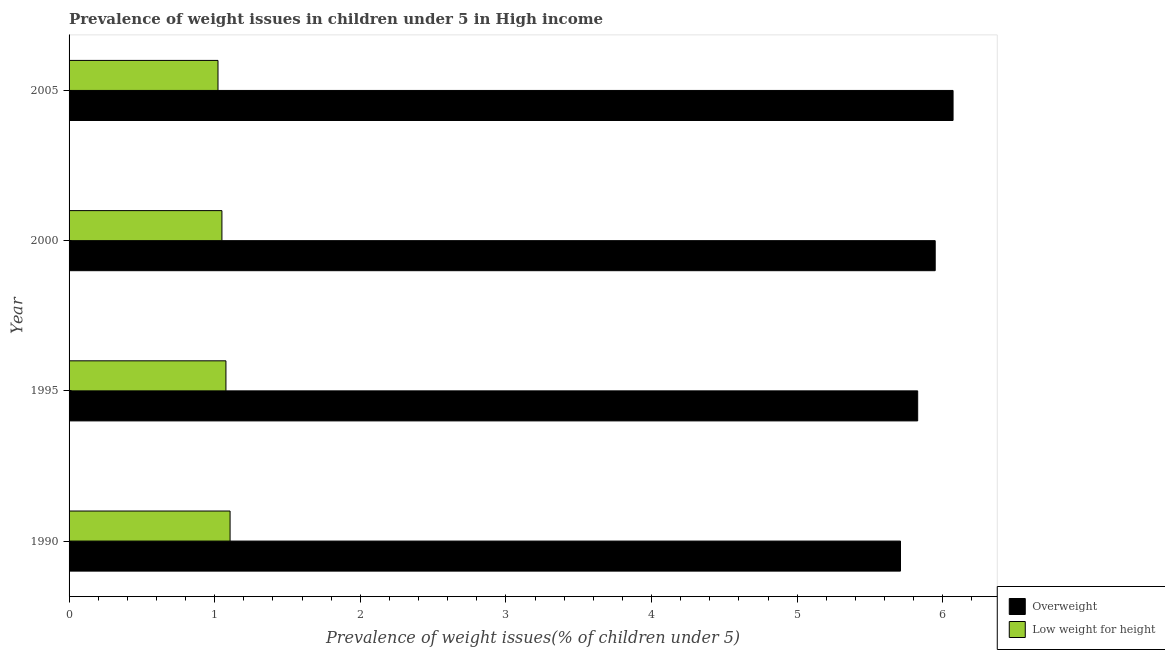Are the number of bars per tick equal to the number of legend labels?
Ensure brevity in your answer.  Yes. How many bars are there on the 4th tick from the bottom?
Ensure brevity in your answer.  2. What is the label of the 3rd group of bars from the top?
Keep it short and to the point. 1995. In how many cases, is the number of bars for a given year not equal to the number of legend labels?
Offer a very short reply. 0. What is the percentage of underweight children in 1995?
Offer a very short reply. 1.08. Across all years, what is the maximum percentage of underweight children?
Give a very brief answer. 1.11. Across all years, what is the minimum percentage of underweight children?
Keep it short and to the point. 1.02. In which year was the percentage of overweight children minimum?
Make the answer very short. 1990. What is the total percentage of underweight children in the graph?
Offer a very short reply. 4.26. What is the difference between the percentage of underweight children in 1995 and that in 2005?
Make the answer very short. 0.06. What is the difference between the percentage of overweight children in 2005 and the percentage of underweight children in 1990?
Keep it short and to the point. 4.96. What is the average percentage of underweight children per year?
Make the answer very short. 1.06. In the year 2000, what is the difference between the percentage of underweight children and percentage of overweight children?
Keep it short and to the point. -4.9. Is the difference between the percentage of underweight children in 1990 and 1995 greater than the difference between the percentage of overweight children in 1990 and 1995?
Provide a succinct answer. Yes. What is the difference between the highest and the second highest percentage of overweight children?
Provide a short and direct response. 0.12. What does the 2nd bar from the top in 1990 represents?
Offer a terse response. Overweight. What does the 2nd bar from the bottom in 1990 represents?
Keep it short and to the point. Low weight for height. Are all the bars in the graph horizontal?
Give a very brief answer. Yes. What is the difference between two consecutive major ticks on the X-axis?
Your answer should be compact. 1. Does the graph contain any zero values?
Keep it short and to the point. No. What is the title of the graph?
Keep it short and to the point. Prevalence of weight issues in children under 5 in High income. What is the label or title of the X-axis?
Your answer should be very brief. Prevalence of weight issues(% of children under 5). What is the label or title of the Y-axis?
Give a very brief answer. Year. What is the Prevalence of weight issues(% of children under 5) of Overweight in 1990?
Your answer should be very brief. 5.71. What is the Prevalence of weight issues(% of children under 5) in Low weight for height in 1990?
Your answer should be compact. 1.11. What is the Prevalence of weight issues(% of children under 5) in Overweight in 1995?
Your response must be concise. 5.83. What is the Prevalence of weight issues(% of children under 5) of Low weight for height in 1995?
Provide a short and direct response. 1.08. What is the Prevalence of weight issues(% of children under 5) of Overweight in 2000?
Give a very brief answer. 5.95. What is the Prevalence of weight issues(% of children under 5) of Low weight for height in 2000?
Your response must be concise. 1.05. What is the Prevalence of weight issues(% of children under 5) in Overweight in 2005?
Give a very brief answer. 6.07. What is the Prevalence of weight issues(% of children under 5) in Low weight for height in 2005?
Give a very brief answer. 1.02. Across all years, what is the maximum Prevalence of weight issues(% of children under 5) in Overweight?
Ensure brevity in your answer.  6.07. Across all years, what is the maximum Prevalence of weight issues(% of children under 5) in Low weight for height?
Keep it short and to the point. 1.11. Across all years, what is the minimum Prevalence of weight issues(% of children under 5) in Overweight?
Make the answer very short. 5.71. Across all years, what is the minimum Prevalence of weight issues(% of children under 5) of Low weight for height?
Offer a terse response. 1.02. What is the total Prevalence of weight issues(% of children under 5) in Overweight in the graph?
Offer a terse response. 23.56. What is the total Prevalence of weight issues(% of children under 5) of Low weight for height in the graph?
Make the answer very short. 4.26. What is the difference between the Prevalence of weight issues(% of children under 5) in Overweight in 1990 and that in 1995?
Your answer should be very brief. -0.12. What is the difference between the Prevalence of weight issues(% of children under 5) of Low weight for height in 1990 and that in 1995?
Your answer should be compact. 0.03. What is the difference between the Prevalence of weight issues(% of children under 5) in Overweight in 1990 and that in 2000?
Provide a succinct answer. -0.24. What is the difference between the Prevalence of weight issues(% of children under 5) of Low weight for height in 1990 and that in 2000?
Provide a succinct answer. 0.06. What is the difference between the Prevalence of weight issues(% of children under 5) in Overweight in 1990 and that in 2005?
Provide a succinct answer. -0.36. What is the difference between the Prevalence of weight issues(% of children under 5) of Low weight for height in 1990 and that in 2005?
Give a very brief answer. 0.08. What is the difference between the Prevalence of weight issues(% of children under 5) in Overweight in 1995 and that in 2000?
Keep it short and to the point. -0.12. What is the difference between the Prevalence of weight issues(% of children under 5) of Low weight for height in 1995 and that in 2000?
Your answer should be compact. 0.03. What is the difference between the Prevalence of weight issues(% of children under 5) in Overweight in 1995 and that in 2005?
Make the answer very short. -0.24. What is the difference between the Prevalence of weight issues(% of children under 5) in Low weight for height in 1995 and that in 2005?
Provide a succinct answer. 0.05. What is the difference between the Prevalence of weight issues(% of children under 5) in Overweight in 2000 and that in 2005?
Provide a short and direct response. -0.12. What is the difference between the Prevalence of weight issues(% of children under 5) of Low weight for height in 2000 and that in 2005?
Provide a succinct answer. 0.03. What is the difference between the Prevalence of weight issues(% of children under 5) of Overweight in 1990 and the Prevalence of weight issues(% of children under 5) of Low weight for height in 1995?
Provide a short and direct response. 4.63. What is the difference between the Prevalence of weight issues(% of children under 5) of Overweight in 1990 and the Prevalence of weight issues(% of children under 5) of Low weight for height in 2000?
Your answer should be very brief. 4.66. What is the difference between the Prevalence of weight issues(% of children under 5) in Overweight in 1990 and the Prevalence of weight issues(% of children under 5) in Low weight for height in 2005?
Give a very brief answer. 4.69. What is the difference between the Prevalence of weight issues(% of children under 5) of Overweight in 1995 and the Prevalence of weight issues(% of children under 5) of Low weight for height in 2000?
Provide a short and direct response. 4.78. What is the difference between the Prevalence of weight issues(% of children under 5) in Overweight in 1995 and the Prevalence of weight issues(% of children under 5) in Low weight for height in 2005?
Your answer should be compact. 4.8. What is the difference between the Prevalence of weight issues(% of children under 5) of Overweight in 2000 and the Prevalence of weight issues(% of children under 5) of Low weight for height in 2005?
Your answer should be compact. 4.93. What is the average Prevalence of weight issues(% of children under 5) of Overweight per year?
Offer a terse response. 5.89. What is the average Prevalence of weight issues(% of children under 5) in Low weight for height per year?
Keep it short and to the point. 1.06. In the year 1990, what is the difference between the Prevalence of weight issues(% of children under 5) of Overweight and Prevalence of weight issues(% of children under 5) of Low weight for height?
Offer a terse response. 4.6. In the year 1995, what is the difference between the Prevalence of weight issues(% of children under 5) in Overweight and Prevalence of weight issues(% of children under 5) in Low weight for height?
Provide a succinct answer. 4.75. In the year 2000, what is the difference between the Prevalence of weight issues(% of children under 5) of Overweight and Prevalence of weight issues(% of children under 5) of Low weight for height?
Your answer should be compact. 4.9. In the year 2005, what is the difference between the Prevalence of weight issues(% of children under 5) of Overweight and Prevalence of weight issues(% of children under 5) of Low weight for height?
Your answer should be compact. 5.05. What is the ratio of the Prevalence of weight issues(% of children under 5) of Overweight in 1990 to that in 1995?
Give a very brief answer. 0.98. What is the ratio of the Prevalence of weight issues(% of children under 5) of Low weight for height in 1990 to that in 1995?
Make the answer very short. 1.03. What is the ratio of the Prevalence of weight issues(% of children under 5) in Overweight in 1990 to that in 2000?
Give a very brief answer. 0.96. What is the ratio of the Prevalence of weight issues(% of children under 5) of Low weight for height in 1990 to that in 2000?
Offer a terse response. 1.05. What is the ratio of the Prevalence of weight issues(% of children under 5) of Overweight in 1990 to that in 2005?
Provide a short and direct response. 0.94. What is the ratio of the Prevalence of weight issues(% of children under 5) of Low weight for height in 1990 to that in 2005?
Your response must be concise. 1.08. What is the ratio of the Prevalence of weight issues(% of children under 5) of Overweight in 1995 to that in 2000?
Give a very brief answer. 0.98. What is the ratio of the Prevalence of weight issues(% of children under 5) in Low weight for height in 1995 to that in 2000?
Offer a very short reply. 1.03. What is the ratio of the Prevalence of weight issues(% of children under 5) of Overweight in 1995 to that in 2005?
Provide a short and direct response. 0.96. What is the ratio of the Prevalence of weight issues(% of children under 5) of Low weight for height in 1995 to that in 2005?
Make the answer very short. 1.05. What is the ratio of the Prevalence of weight issues(% of children under 5) in Overweight in 2000 to that in 2005?
Your answer should be very brief. 0.98. What is the ratio of the Prevalence of weight issues(% of children under 5) of Low weight for height in 2000 to that in 2005?
Your answer should be very brief. 1.03. What is the difference between the highest and the second highest Prevalence of weight issues(% of children under 5) in Overweight?
Your response must be concise. 0.12. What is the difference between the highest and the second highest Prevalence of weight issues(% of children under 5) of Low weight for height?
Offer a very short reply. 0.03. What is the difference between the highest and the lowest Prevalence of weight issues(% of children under 5) of Overweight?
Your response must be concise. 0.36. What is the difference between the highest and the lowest Prevalence of weight issues(% of children under 5) in Low weight for height?
Your response must be concise. 0.08. 